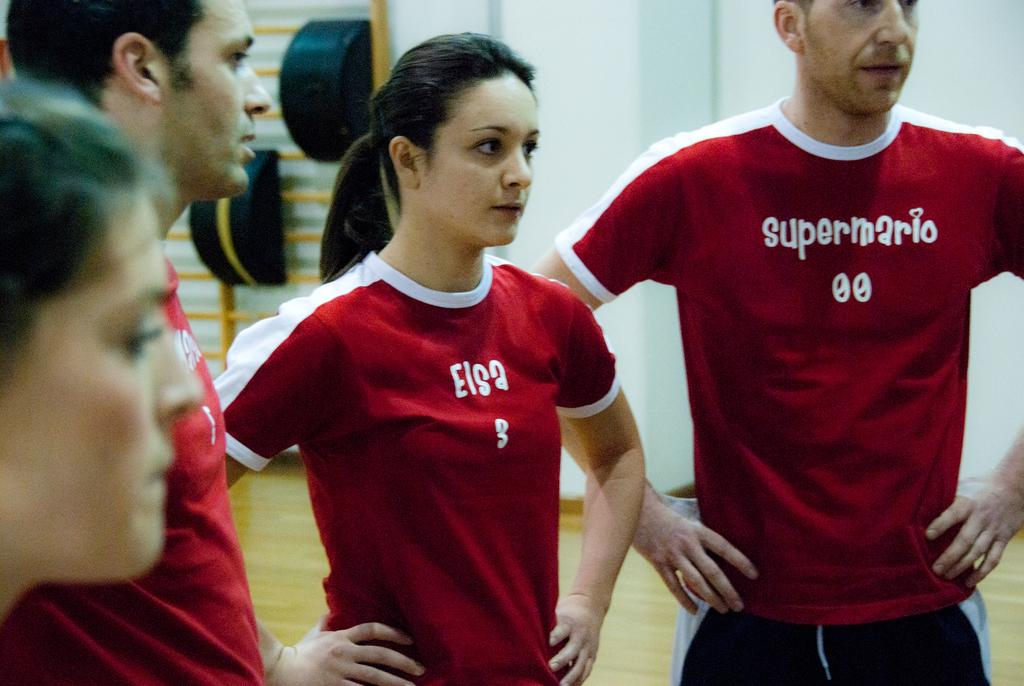<image>
Describe the image concisely. A man in a supermario shirt has the number 00 on this team. 